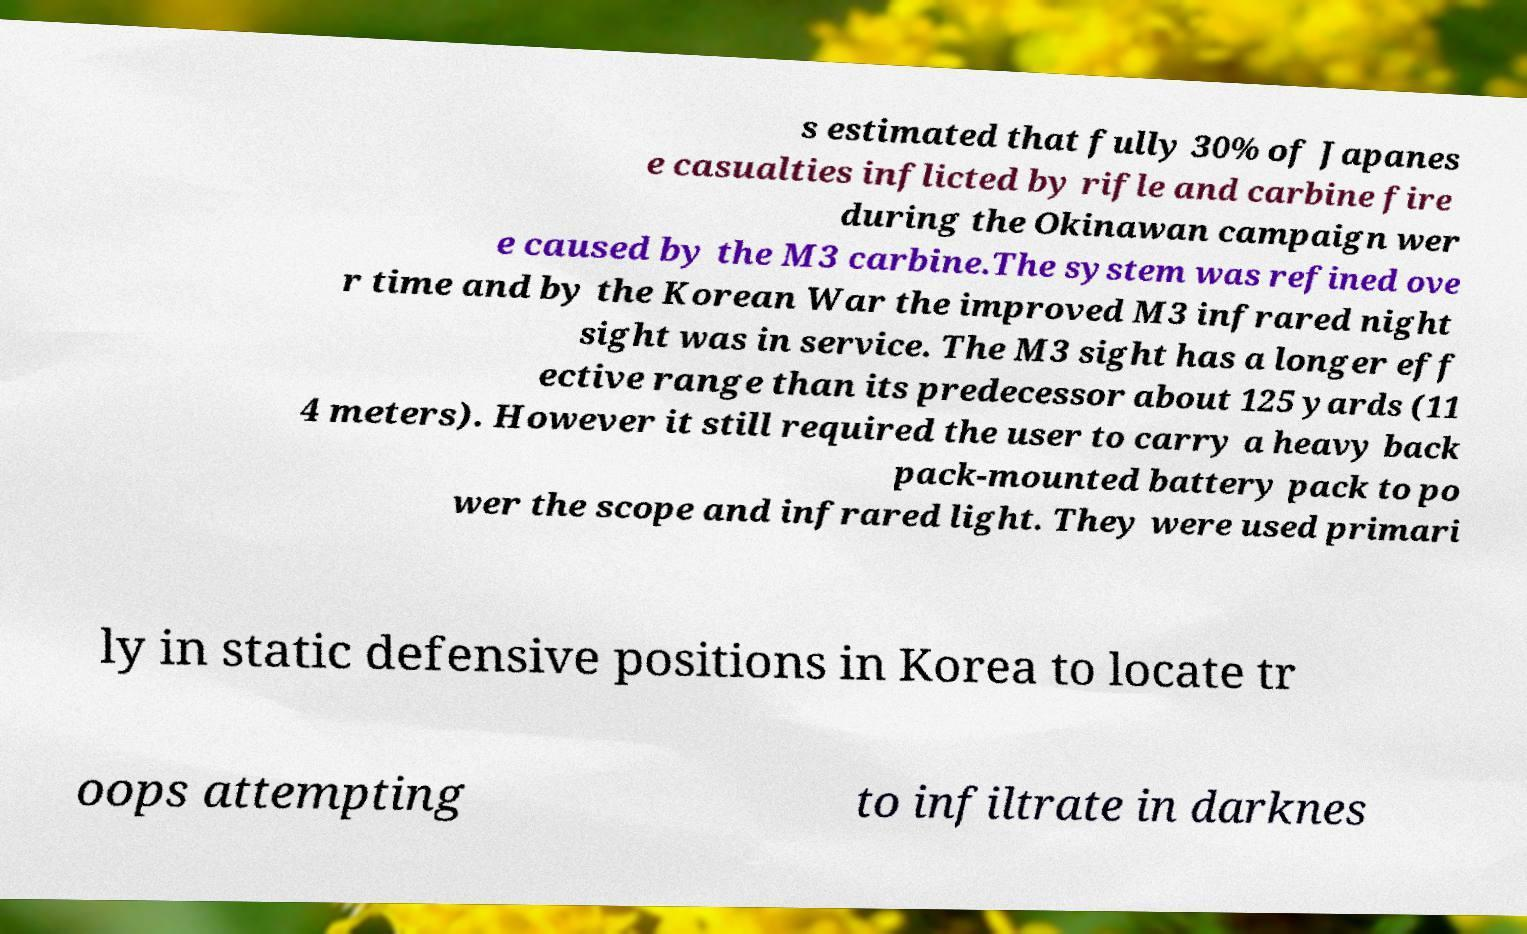Can you read and provide the text displayed in the image?This photo seems to have some interesting text. Can you extract and type it out for me? s estimated that fully 30% of Japanes e casualties inflicted by rifle and carbine fire during the Okinawan campaign wer e caused by the M3 carbine.The system was refined ove r time and by the Korean War the improved M3 infrared night sight was in service. The M3 sight has a longer eff ective range than its predecessor about 125 yards (11 4 meters). However it still required the user to carry a heavy back pack-mounted battery pack to po wer the scope and infrared light. They were used primari ly in static defensive positions in Korea to locate tr oops attempting to infiltrate in darknes 